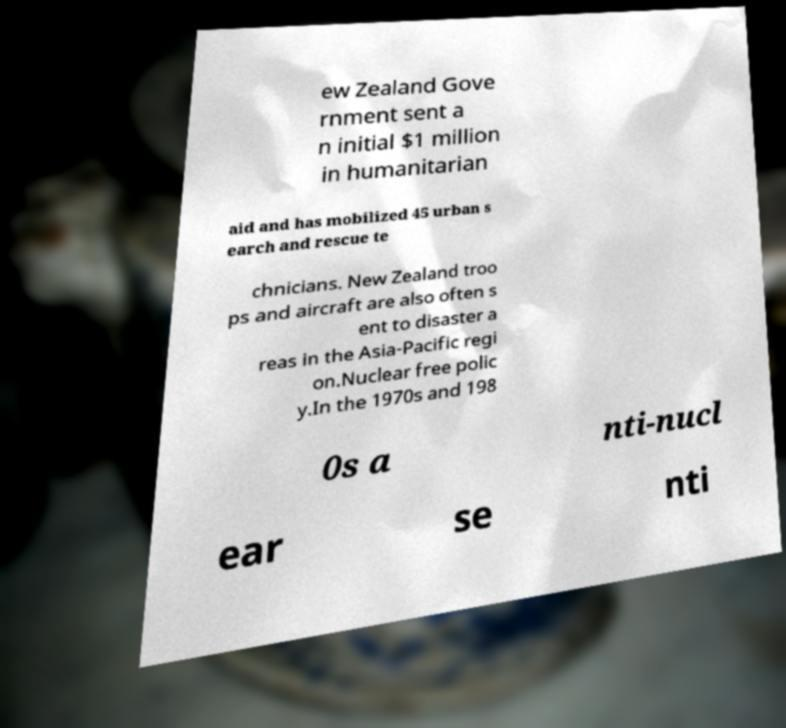Can you read and provide the text displayed in the image?This photo seems to have some interesting text. Can you extract and type it out for me? ew Zealand Gove rnment sent a n initial $1 million in humanitarian aid and has mobilized 45 urban s earch and rescue te chnicians. New Zealand troo ps and aircraft are also often s ent to disaster a reas in the Asia-Pacific regi on.Nuclear free polic y.In the 1970s and 198 0s a nti-nucl ear se nti 